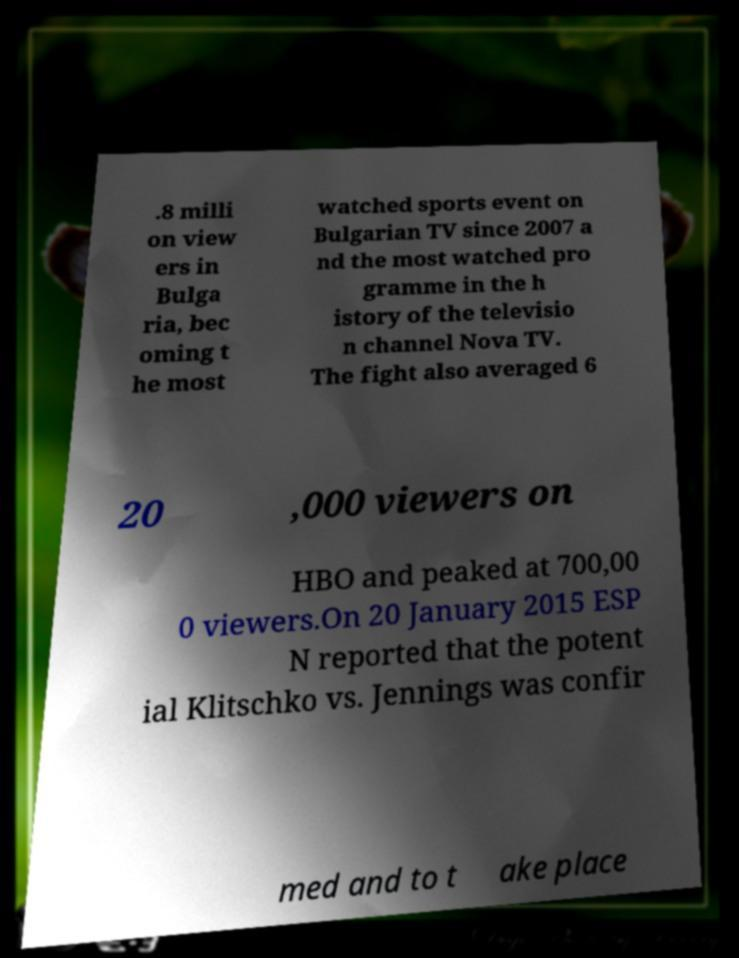Could you extract and type out the text from this image? .8 milli on view ers in Bulga ria, bec oming t he most watched sports event on Bulgarian TV since 2007 a nd the most watched pro gramme in the h istory of the televisio n channel Nova TV. The fight also averaged 6 20 ,000 viewers on HBO and peaked at 700,00 0 viewers.On 20 January 2015 ESP N reported that the potent ial Klitschko vs. Jennings was confir med and to t ake place 